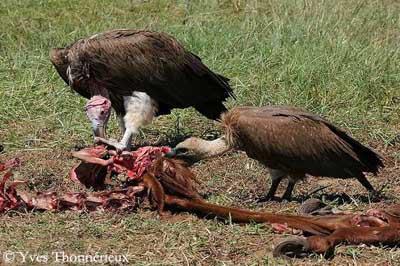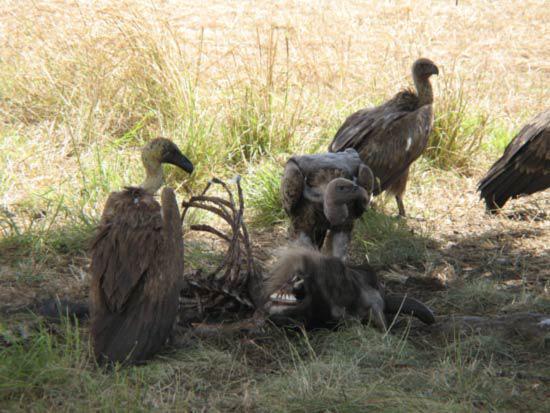The first image is the image on the left, the second image is the image on the right. Assess this claim about the two images: "In the image to the left, vultures feed.". Correct or not? Answer yes or no. Yes. The first image is the image on the left, the second image is the image on the right. For the images displayed, is the sentence "there is at least one image with a vulture with wings spread" factually correct? Answer yes or no. No. 